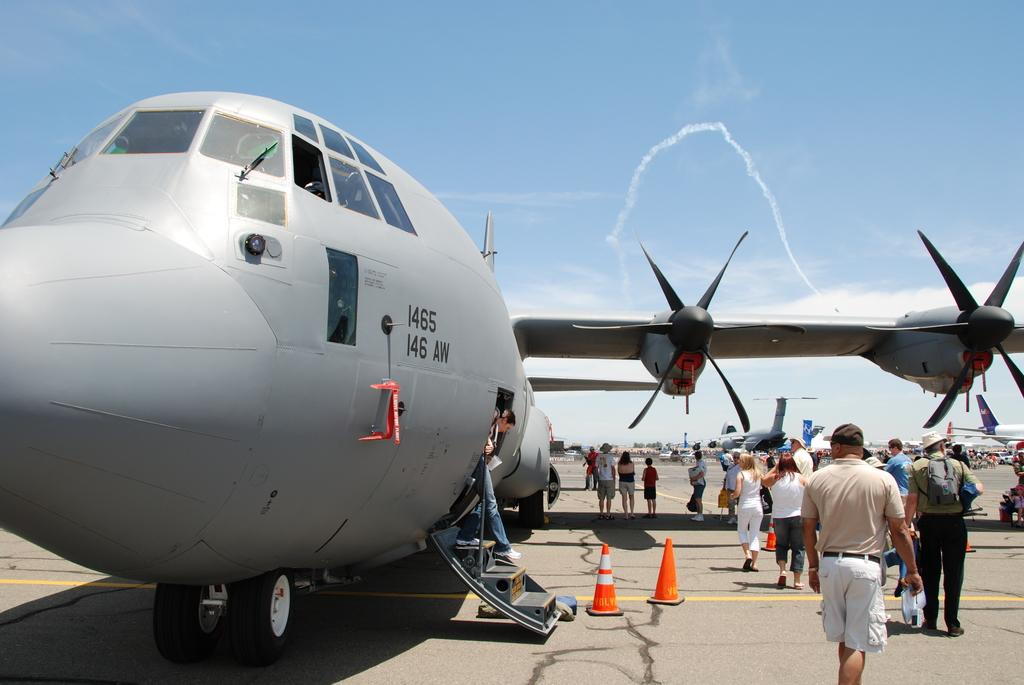<image>
Provide a brief description of the given image. A group of people stand outside of a large propeller plane with the numerals 1465 on it. 